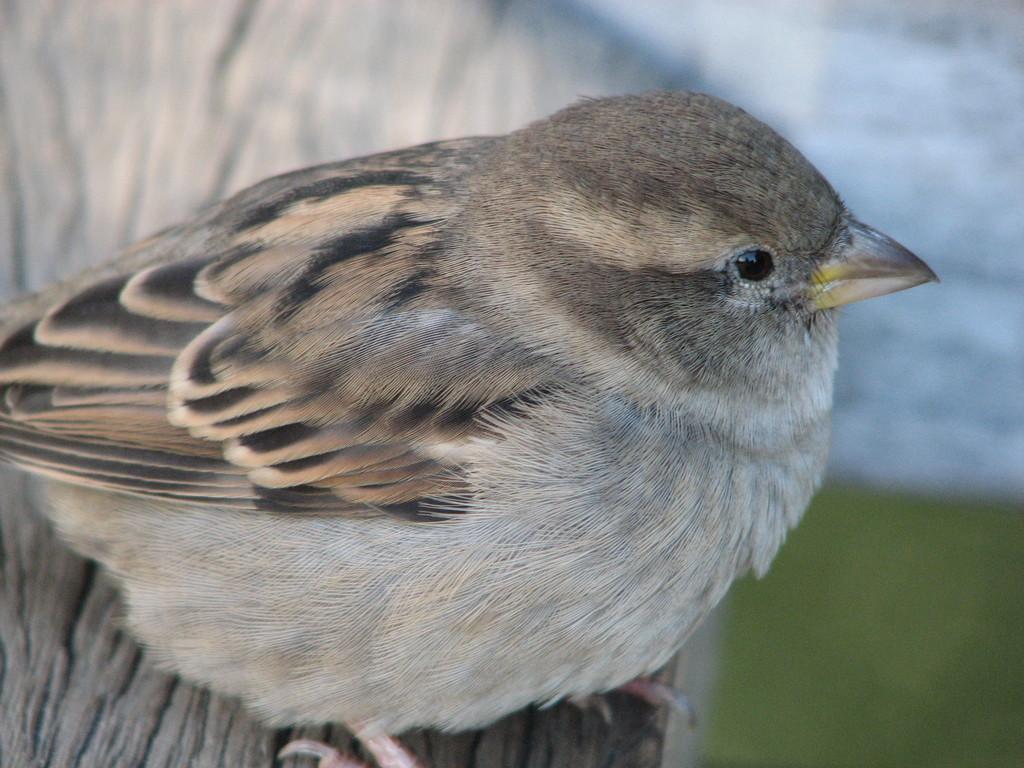In one or two sentences, can you explain what this image depicts? In this image we can see a bird on the surface. 